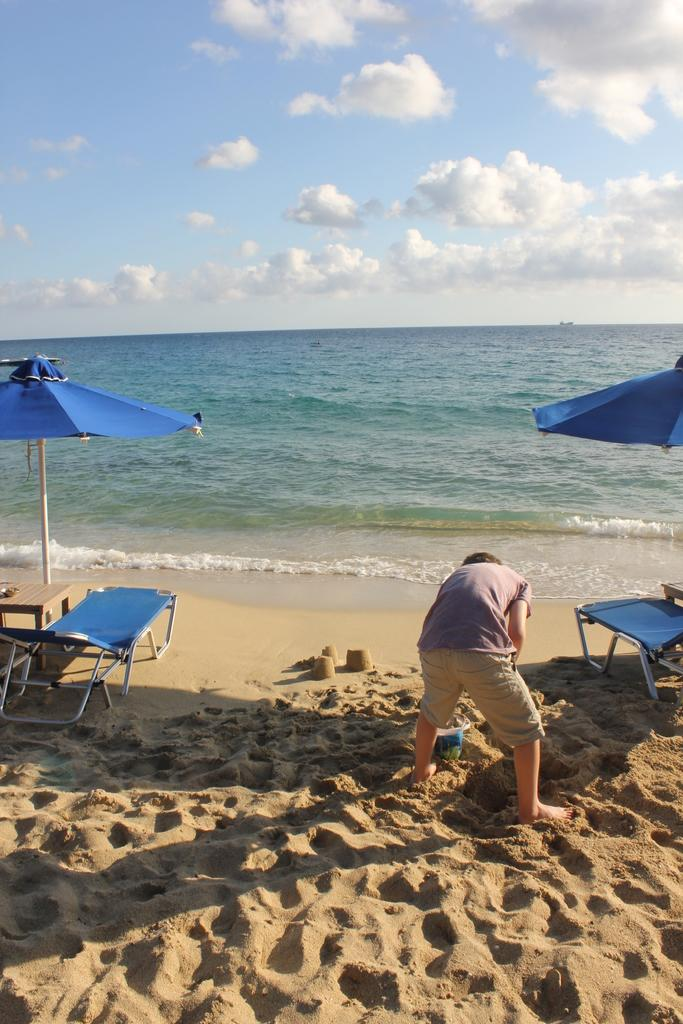What is the primary subject in the image? There is a person standing in the image. What type of furniture can be seen in the image? There are chairs and tables in the image. What type of shelter is provided in the image? There are umbrellas in the image. What natural elements are visible in the image? Water and sand are visible in the image. What part of the environment is visible in the image? The sky is visible in the image. What type of arch can be seen in the image? There is no arch present in the image. What type of space is visible in the image? The image does not depict any space-related elements; it is set in an outdoor environment with water, sand, and sky. What type of baseball equipment is visible in the image? There is no baseball equipment present in the image. 